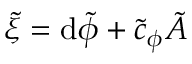<formula> <loc_0><loc_0><loc_500><loc_500>\tilde { \xi } = d \tilde { \phi } + \tilde { c } _ { \phi } \tilde { A }</formula> 